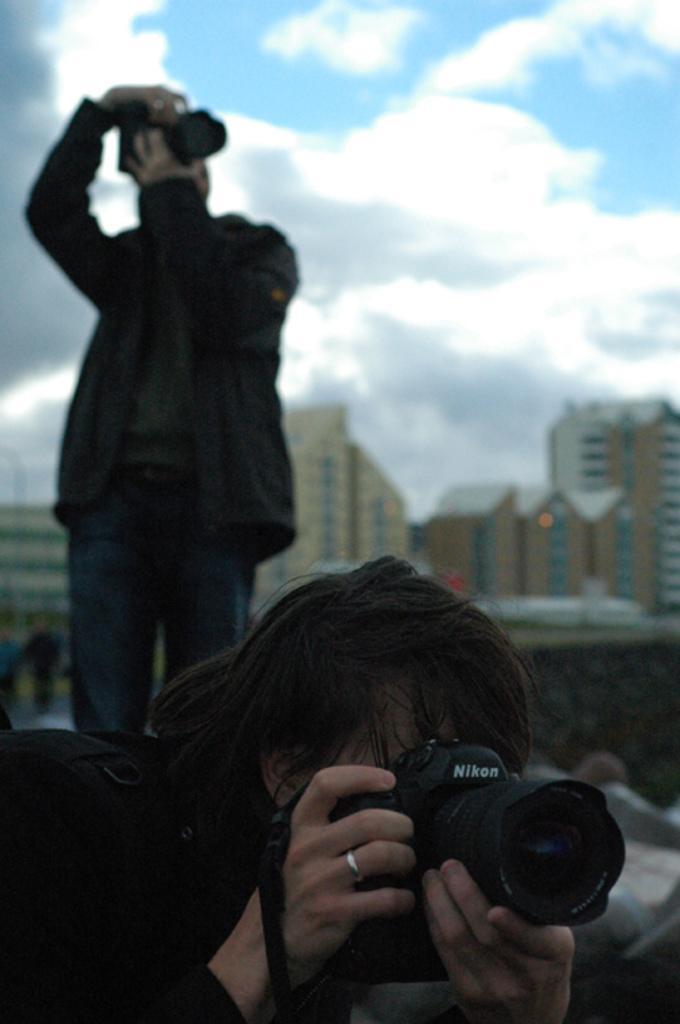Can you describe this image briefly? In this image there are two person the man is standing. And the climate looks cloudy. In the background there are tall buildings. Both the persons are capturing the pictures through a cameras. 